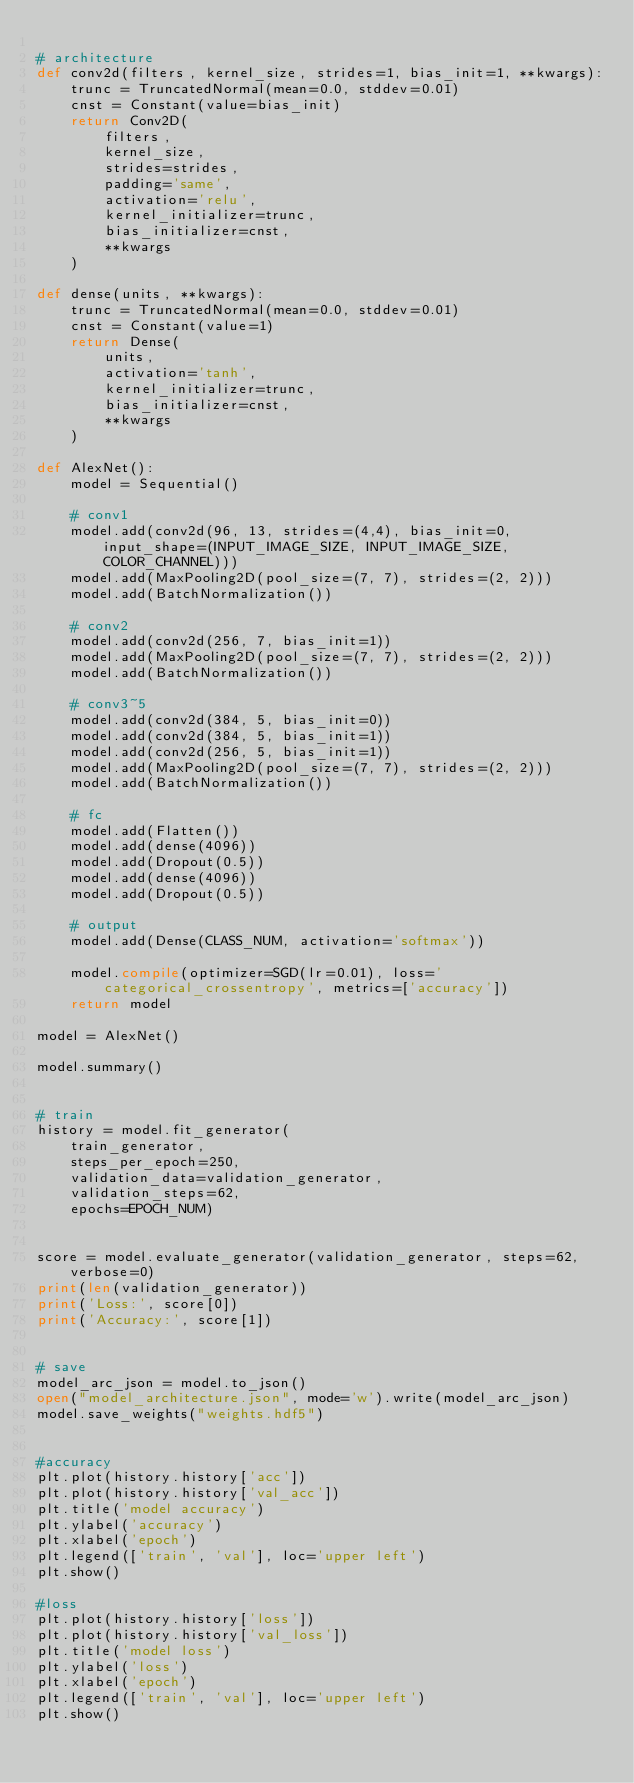<code> <loc_0><loc_0><loc_500><loc_500><_Python_>
# architecture
def conv2d(filters, kernel_size, strides=1, bias_init=1, **kwargs):
    trunc = TruncatedNormal(mean=0.0, stddev=0.01)
    cnst = Constant(value=bias_init)
    return Conv2D(
        filters,
        kernel_size,
        strides=strides,
        padding='same',
        activation='relu',
        kernel_initializer=trunc,
        bias_initializer=cnst,
        **kwargs
    )

def dense(units, **kwargs):
    trunc = TruncatedNormal(mean=0.0, stddev=0.01)
    cnst = Constant(value=1)
    return Dense(
        units,
        activation='tanh',
        kernel_initializer=trunc,
        bias_initializer=cnst,
        **kwargs
    )

def AlexNet():
    model = Sequential()

    # conv1
    model.add(conv2d(96, 13, strides=(4,4), bias_init=0, input_shape=(INPUT_IMAGE_SIZE, INPUT_IMAGE_SIZE, COLOR_CHANNEL)))
    model.add(MaxPooling2D(pool_size=(7, 7), strides=(2, 2)))
    model.add(BatchNormalization())

    # conv2
    model.add(conv2d(256, 7, bias_init=1))
    model.add(MaxPooling2D(pool_size=(7, 7), strides=(2, 2)))
    model.add(BatchNormalization())

    # conv3~5
    model.add(conv2d(384, 5, bias_init=0))
    model.add(conv2d(384, 5, bias_init=1))
    model.add(conv2d(256, 5, bias_init=1))
    model.add(MaxPooling2D(pool_size=(7, 7), strides=(2, 2)))
    model.add(BatchNormalization())

    # fc
    model.add(Flatten())
    model.add(dense(4096))
    model.add(Dropout(0.5))
    model.add(dense(4096))
    model.add(Dropout(0.5))

    # output
    model.add(Dense(CLASS_NUM, activation='softmax'))

    model.compile(optimizer=SGD(lr=0.01), loss='categorical_crossentropy', metrics=['accuracy'])
    return model

model = AlexNet()

model.summary()


# train
history = model.fit_generator(
    train_generator,
    steps_per_epoch=250, 
    validation_data=validation_generator,
    validation_steps=62,
    epochs=EPOCH_NUM)


score = model.evaluate_generator(validation_generator, steps=62, verbose=0)
print(len(validation_generator))
print('Loss:', score[0])
print('Accuracy:', score[1])


# save
model_arc_json = model.to_json()
open("model_architecture.json", mode='w').write(model_arc_json)
model.save_weights("weights.hdf5")


#accuracy
plt.plot(history.history['acc'])
plt.plot(history.history['val_acc'])
plt.title('model accuracy')
plt.ylabel('accuracy')
plt.xlabel('epoch')
plt.legend(['train', 'val'], loc='upper left')
plt.show()

#loss
plt.plot(history.history['loss'])
plt.plot(history.history['val_loss'])
plt.title('model loss')
plt.ylabel('loss')
plt.xlabel('epoch')
plt.legend(['train', 'val'], loc='upper left')
plt.show()

</code> 